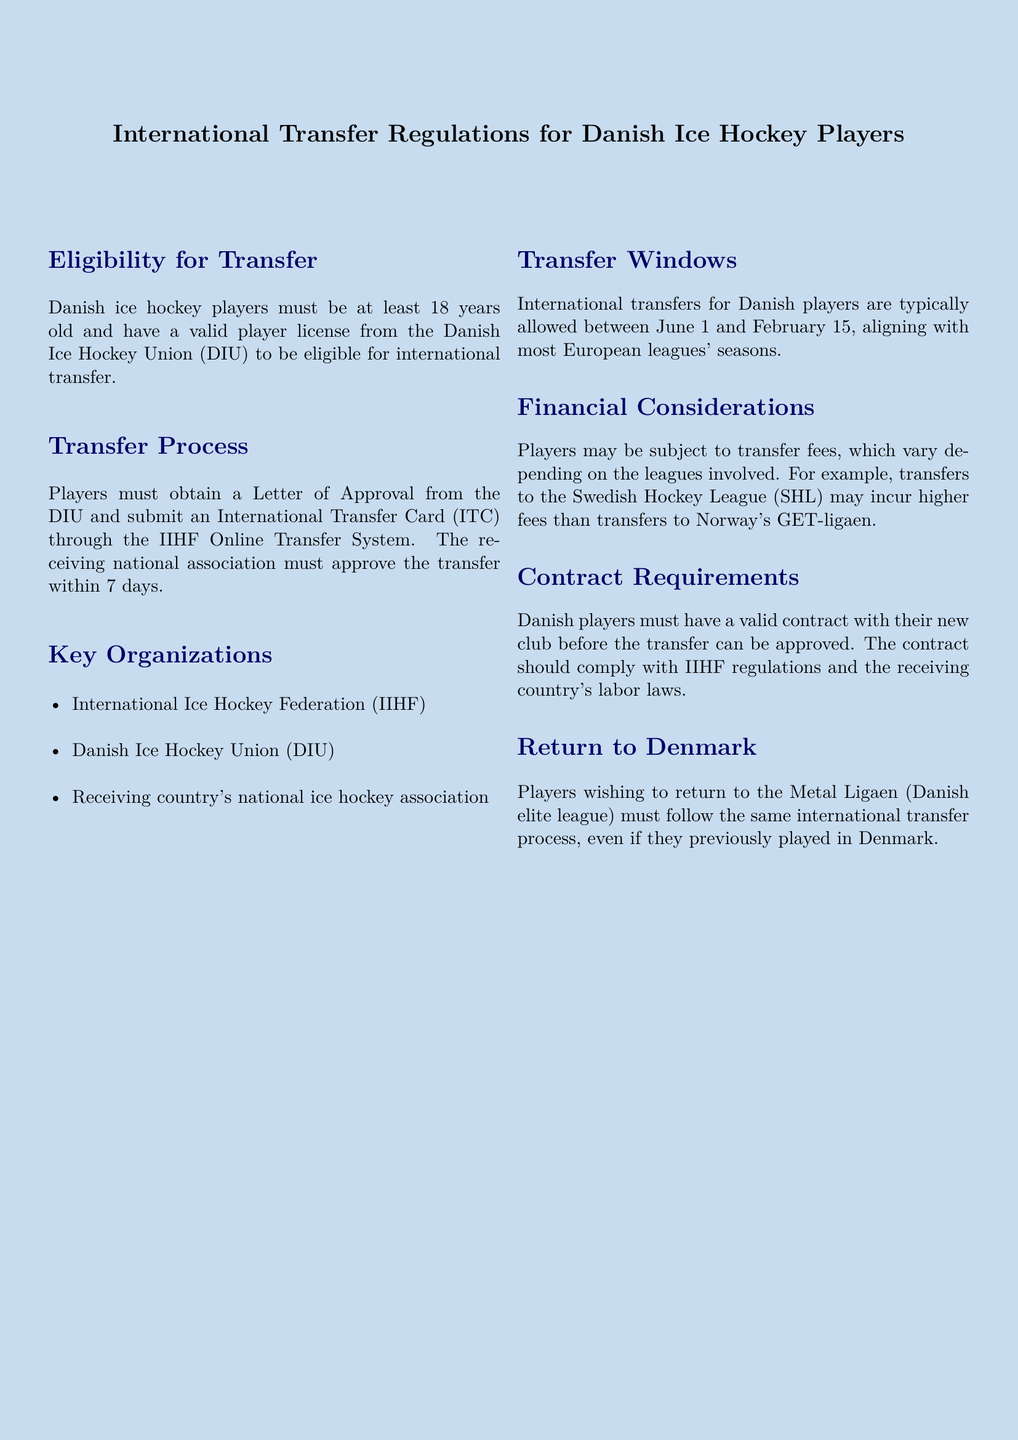What is the minimum age for international transfer eligibility? The minimum age for eligibility is stated as "at least 18 years old" in the document.
Answer: 18 What is required from the Danish Ice Hockey Union for a player to transfer? Players must obtain a "Letter of Approval" from the DIU to initiate the transfer process.
Answer: Letter of Approval What is the transfer window period for Danish players? The document specifies the transfer window is "between June 1 and February 15."
Answer: June 1 and February 15 What must a Danish player submit to the IIHF Online Transfer System? Players must submit an "International Transfer Card (ITC)" to the IIHF Online Transfer System for processing.
Answer: International Transfer Card (ITC) Which league may incur higher transfer fees? The document mentions that "transfers to the Swedish Hockey League (SHL) may incur higher fees" than other leagues.
Answer: Swedish Hockey League (SHL) What must a player have before their transfer can be approved? The document states that players must have a "valid contract with their new club" before the approval of the transfer.
Answer: valid contract What must players do to return to the Metal Ligaen? Players wishing to return to the Metal Ligaen must "follow the same international transfer process."
Answer: same international transfer process Name one of the key organizations involved in the transfer process. The document lists "International Ice Hockey Federation (IIHF)" as one of the key organizations.
Answer: International Ice Hockey Federation (IIHF) What is the approval timeframe for the receiving national association? The document states that the receiving national association must approve the transfer "within 7 days."
Answer: 7 days 